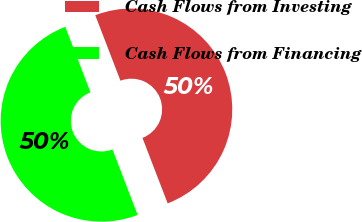Convert chart to OTSL. <chart><loc_0><loc_0><loc_500><loc_500><pie_chart><fcel>Cash Flows from Investing<fcel>Cash Flows from Financing<nl><fcel>50.0%<fcel>50.0%<nl></chart> 